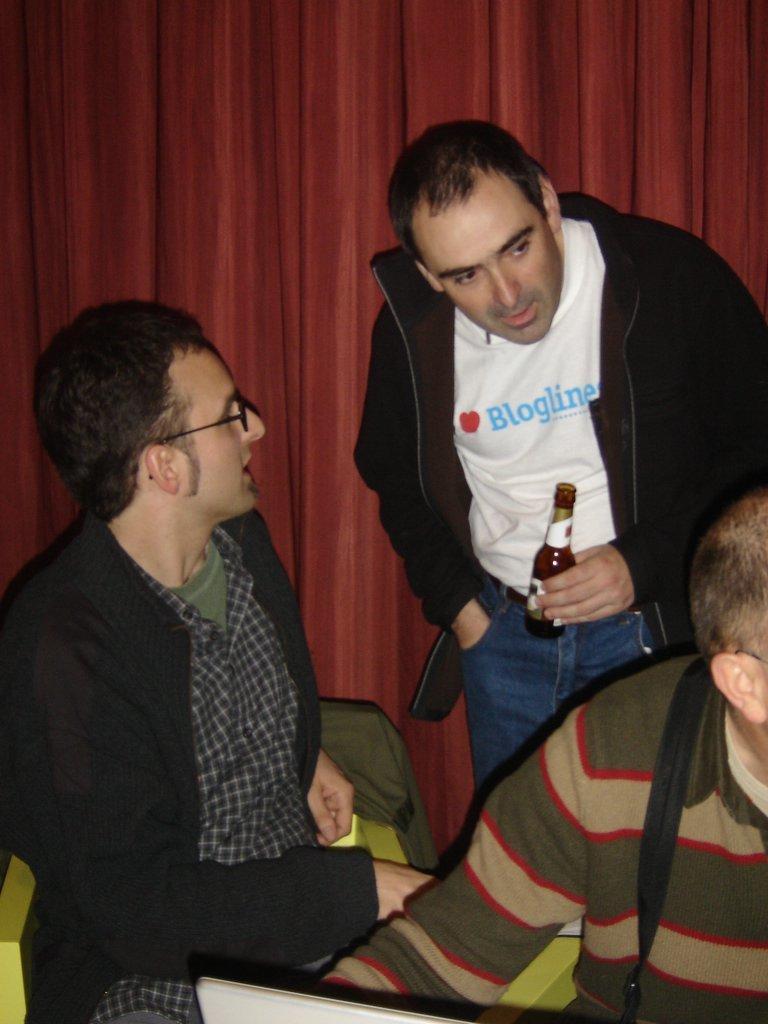Please provide a concise description of this image. In the image in the center,we can see two people were sitting and one man standing and holding wine bottle. In the background there is a curtain. 